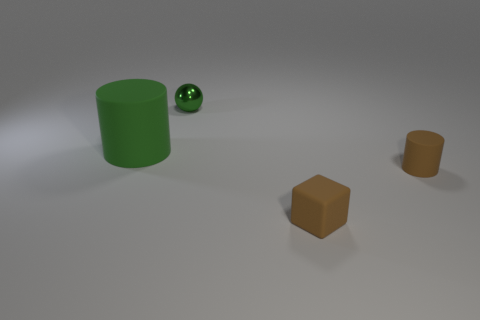Are there any other things that have the same size as the green cylinder?
Offer a terse response. No. There is a big cylinder that is the same color as the ball; what is its material?
Offer a terse response. Rubber. What number of other things have the same color as the shiny thing?
Keep it short and to the point. 1. What material is the green object in front of the green thing behind the green thing to the left of the small metallic sphere made of?
Your answer should be very brief. Rubber. What is the color of the rubber object that is to the right of the matte thing in front of the tiny cylinder?
Your response must be concise. Brown. What number of tiny objects are either red metal spheres or green matte things?
Ensure brevity in your answer.  0. How many small blocks have the same material as the tiny cylinder?
Make the answer very short. 1. There is a matte thing right of the brown rubber cube; how big is it?
Give a very brief answer. Small. What is the shape of the tiny brown thing left of the cylinder on the right side of the green shiny object?
Your answer should be compact. Cube. How many spheres are to the right of the tiny brown thing that is on the left side of the cylinder in front of the large thing?
Make the answer very short. 0. 